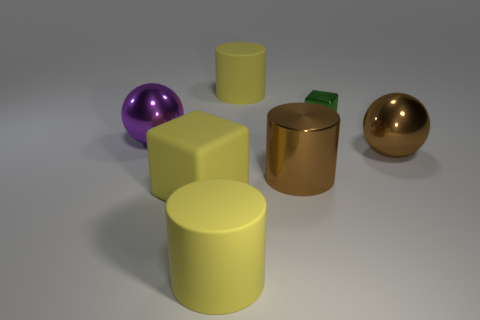There is a large shiny cylinder; is its color the same as the rubber cylinder in front of the large cube?
Make the answer very short. No. Are there any other objects that have the same size as the purple metal object?
Give a very brief answer. Yes. What size is the brown cylinder in front of the purple object?
Make the answer very short. Large. There is a yellow rubber object that is behind the metallic cube; are there any brown metal cylinders to the left of it?
Give a very brief answer. No. How many other objects are there of the same shape as the green metallic object?
Offer a very short reply. 1. Do the tiny green object and the big purple shiny object have the same shape?
Your answer should be compact. No. There is a large shiny object that is both behind the big brown cylinder and right of the big cube; what color is it?
Ensure brevity in your answer.  Brown. The shiny ball that is the same color as the metallic cylinder is what size?
Offer a terse response. Large. What number of small objects are blue balls or purple objects?
Provide a succinct answer. 0. Are there any other things that are the same color as the tiny object?
Your answer should be compact. No. 